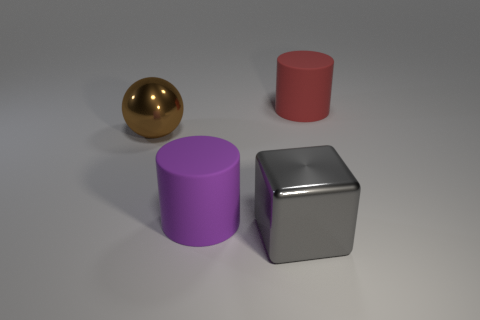Add 1 big cyan metallic cylinders. How many objects exist? 5 Subtract all blocks. How many objects are left? 3 Subtract 0 gray cylinders. How many objects are left? 4 Subtract all metal blocks. Subtract all small red rubber cubes. How many objects are left? 3 Add 3 gray things. How many gray things are left? 4 Add 2 gray metallic objects. How many gray metallic objects exist? 3 